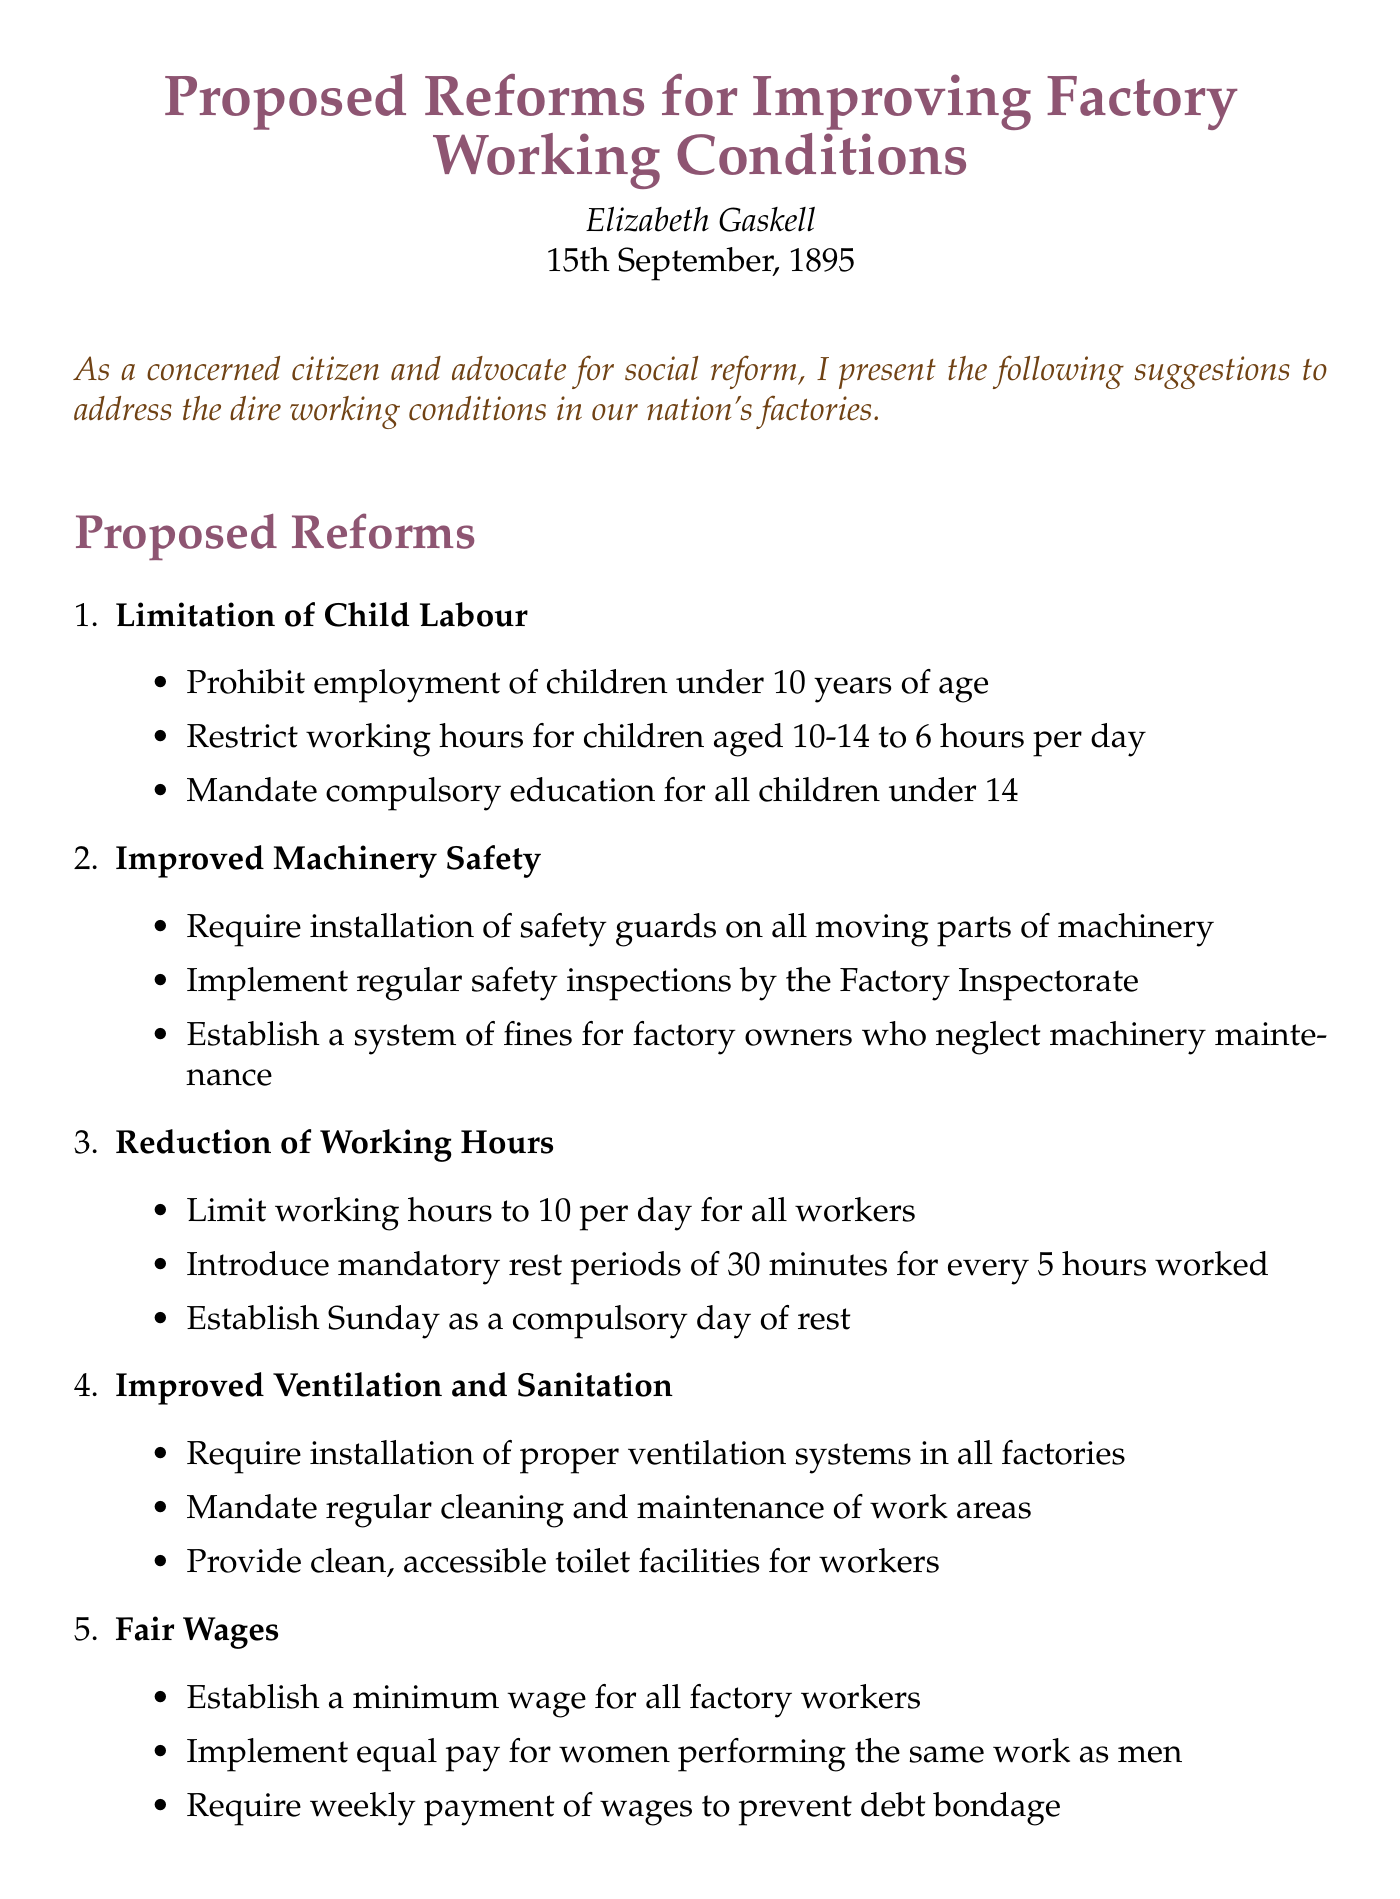What is the title of the memo? The title of the memo is explicitly stated at the beginning of the document.
Answer: Proposed Reforms for Improving Factory Working Conditions Who is the author of the memo? The author of the memo is mentioned in the introductory section.
Answer: Elizabeth Gaskell What date was the memo written? The date is presented in the header of the document.
Answer: 15th September, 1895 What is one of the proposed reforms listed in the document? The document provides a list of reforms, and any single one can be identified.
Answer: Limitation of Child Labour What is mandated for children under 14 as part of the proposed reforms? A specific requirement for children under 14 is outlined among the proposed reforms.
Answer: Compulsory education How many organizations are listed as supporting organizations? The number of supporting organizations can be counted from the relevant section of the document.
Answer: 3 What is the suggested maximum working hours for all workers? The maximum working hours are stated clearly in the proposed reforms for reduction of working hours.
Answer: 10 per day What does the conclusion urge Parliament and factory owners to do? The conclusion expresses a specific request addressed to Parliament and factory owners.
Answer: Consider these measures What is one safety measure proposed for machinery? The document outlines various safety measures taken to improve machinery safety.
Answer: Installation of safety guards 